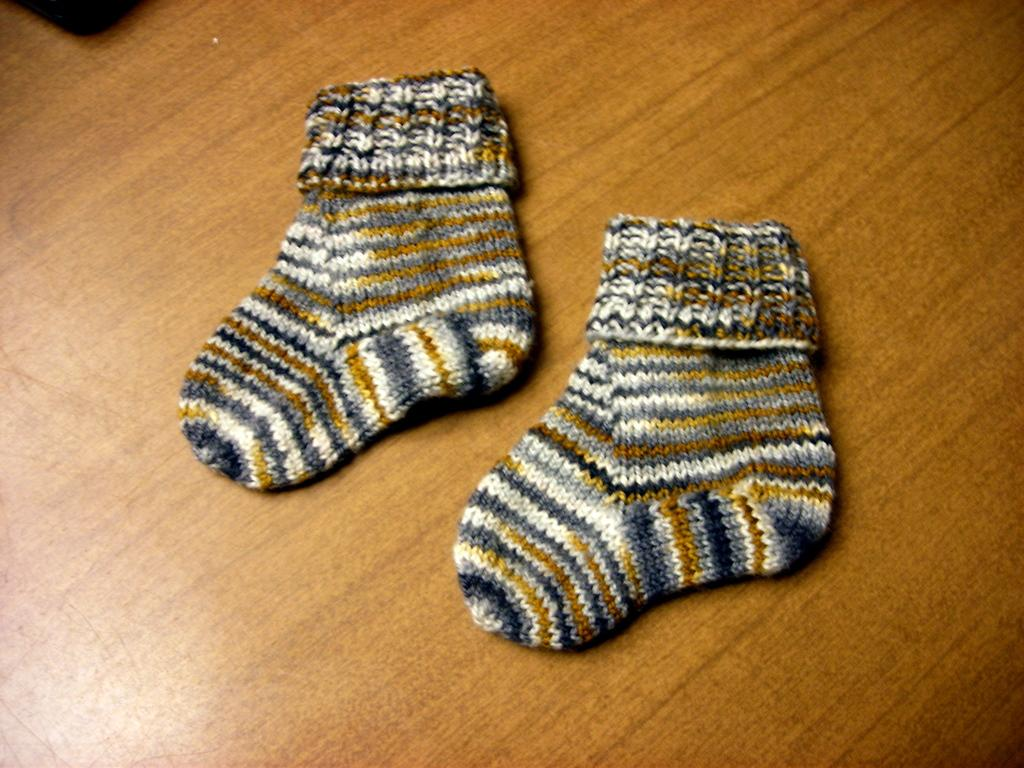What type of clothing item is in the image? There is a pair of socks in the image. What color is the black object in the image? The black object in the image is not specified, but it is mentioned that it is black. On what surface are the objects placed? The objects are on a wooden table. Who is the servant attending to in the image? There is no servant present in the image. What type of lift is visible in the image? There is no lift present in the image. 